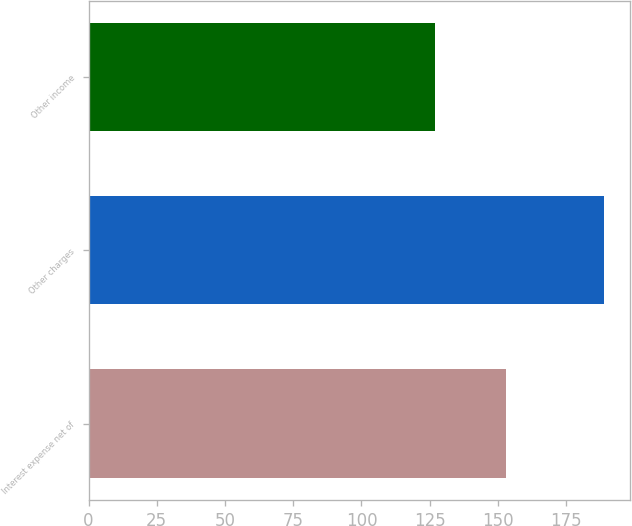Convert chart. <chart><loc_0><loc_0><loc_500><loc_500><bar_chart><fcel>Interest expense net of<fcel>Other charges<fcel>Other income<nl><fcel>153<fcel>189<fcel>127<nl></chart> 